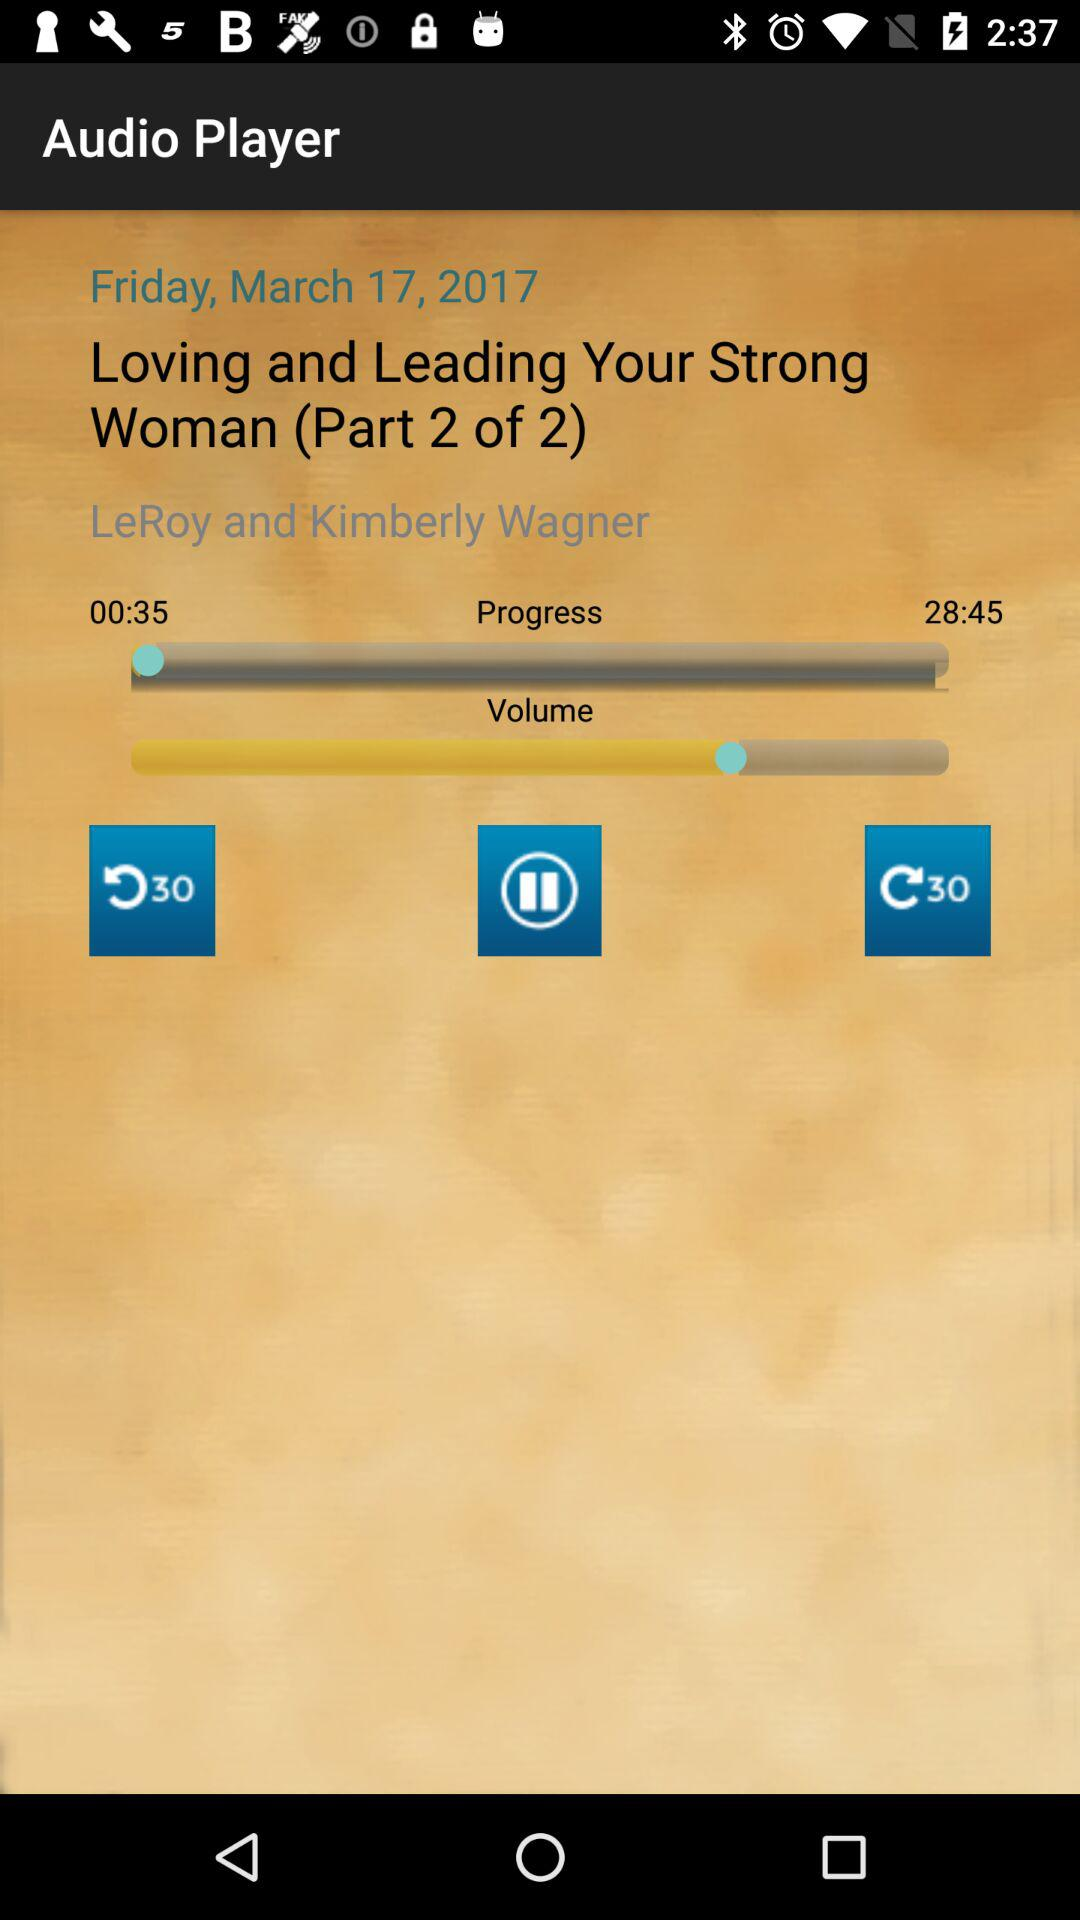How long ago was the podcast uploaded?
Answer the question using a single word or phrase. Friday, March 17, 2017 